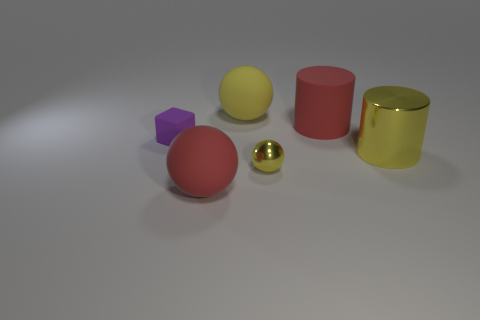Subtract all green spheres. Subtract all purple cubes. How many spheres are left? 3 Add 2 red cylinders. How many objects exist? 8 Subtract all blocks. How many objects are left? 5 Add 1 big yellow objects. How many big yellow objects are left? 3 Add 4 large red rubber things. How many large red rubber things exist? 6 Subtract 0 brown blocks. How many objects are left? 6 Subtract all purple matte balls. Subtract all shiny objects. How many objects are left? 4 